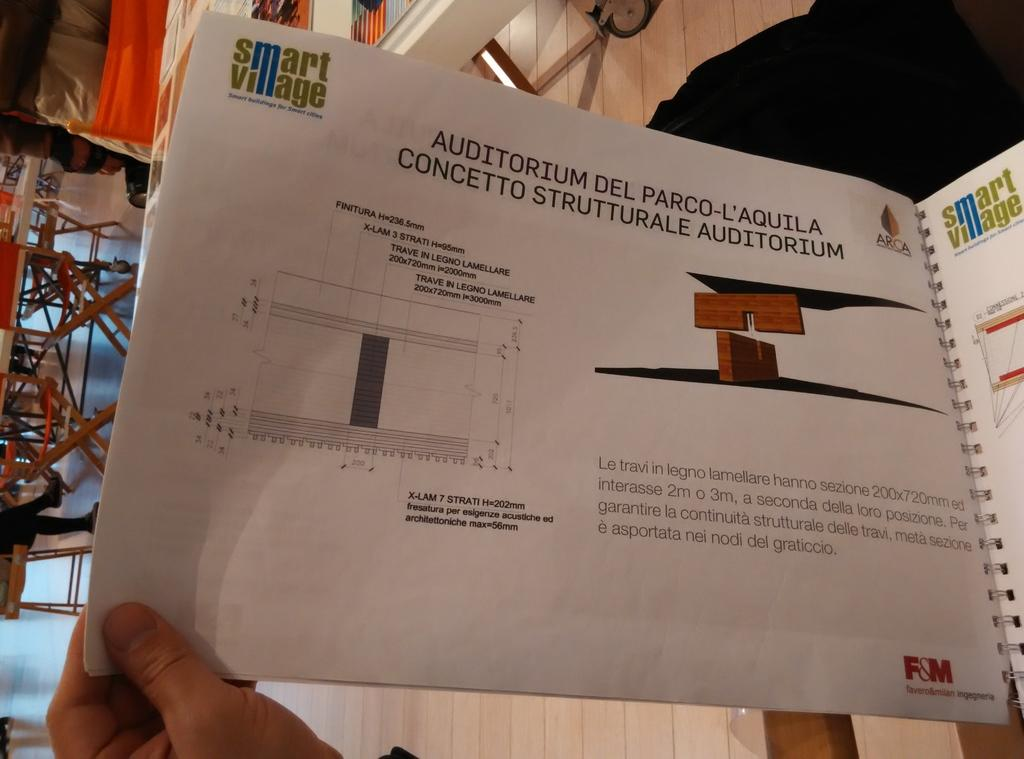<image>
Share a concise interpretation of the image provided. A book is open to a page about Auditorium Del Parco L'Aquila 